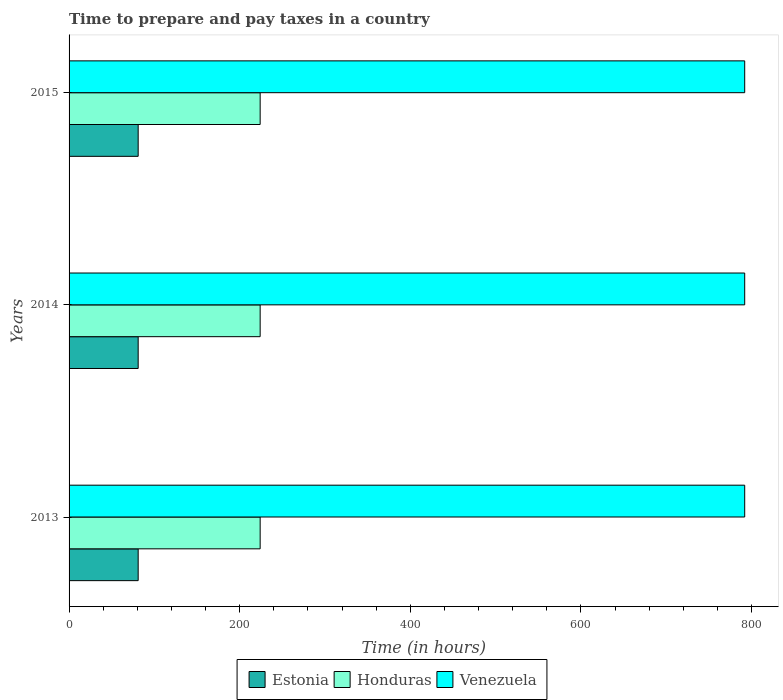How many bars are there on the 2nd tick from the top?
Provide a short and direct response. 3. In how many cases, is the number of bars for a given year not equal to the number of legend labels?
Offer a terse response. 0. What is the number of hours required to prepare and pay taxes in Venezuela in 2014?
Give a very brief answer. 792. Across all years, what is the maximum number of hours required to prepare and pay taxes in Venezuela?
Make the answer very short. 792. Across all years, what is the minimum number of hours required to prepare and pay taxes in Venezuela?
Your answer should be compact. 792. In which year was the number of hours required to prepare and pay taxes in Venezuela maximum?
Give a very brief answer. 2013. What is the total number of hours required to prepare and pay taxes in Honduras in the graph?
Provide a succinct answer. 672. What is the difference between the number of hours required to prepare and pay taxes in Honduras in 2014 and the number of hours required to prepare and pay taxes in Venezuela in 2015?
Ensure brevity in your answer.  -568. What is the average number of hours required to prepare and pay taxes in Honduras per year?
Offer a very short reply. 224. In the year 2013, what is the difference between the number of hours required to prepare and pay taxes in Honduras and number of hours required to prepare and pay taxes in Estonia?
Your answer should be very brief. 143. In how many years, is the number of hours required to prepare and pay taxes in Honduras greater than 440 hours?
Ensure brevity in your answer.  0. Is the difference between the number of hours required to prepare and pay taxes in Honduras in 2013 and 2015 greater than the difference between the number of hours required to prepare and pay taxes in Estonia in 2013 and 2015?
Your answer should be compact. No. Is the sum of the number of hours required to prepare and pay taxes in Estonia in 2014 and 2015 greater than the maximum number of hours required to prepare and pay taxes in Venezuela across all years?
Your response must be concise. No. What does the 2nd bar from the top in 2013 represents?
Offer a terse response. Honduras. What does the 1st bar from the bottom in 2013 represents?
Give a very brief answer. Estonia. How many bars are there?
Offer a terse response. 9. Are all the bars in the graph horizontal?
Offer a very short reply. Yes. Does the graph contain any zero values?
Provide a short and direct response. No. Where does the legend appear in the graph?
Make the answer very short. Bottom center. How many legend labels are there?
Keep it short and to the point. 3. What is the title of the graph?
Ensure brevity in your answer.  Time to prepare and pay taxes in a country. Does "Kenya" appear as one of the legend labels in the graph?
Provide a short and direct response. No. What is the label or title of the X-axis?
Your response must be concise. Time (in hours). What is the label or title of the Y-axis?
Ensure brevity in your answer.  Years. What is the Time (in hours) in Estonia in 2013?
Your answer should be compact. 81. What is the Time (in hours) in Honduras in 2013?
Provide a short and direct response. 224. What is the Time (in hours) in Venezuela in 2013?
Keep it short and to the point. 792. What is the Time (in hours) of Estonia in 2014?
Your answer should be compact. 81. What is the Time (in hours) of Honduras in 2014?
Offer a very short reply. 224. What is the Time (in hours) in Venezuela in 2014?
Offer a very short reply. 792. What is the Time (in hours) in Honduras in 2015?
Offer a very short reply. 224. What is the Time (in hours) of Venezuela in 2015?
Provide a succinct answer. 792. Across all years, what is the maximum Time (in hours) in Honduras?
Your answer should be compact. 224. Across all years, what is the maximum Time (in hours) of Venezuela?
Keep it short and to the point. 792. Across all years, what is the minimum Time (in hours) of Estonia?
Your answer should be compact. 81. Across all years, what is the minimum Time (in hours) in Honduras?
Provide a short and direct response. 224. Across all years, what is the minimum Time (in hours) of Venezuela?
Offer a very short reply. 792. What is the total Time (in hours) of Estonia in the graph?
Your answer should be very brief. 243. What is the total Time (in hours) of Honduras in the graph?
Your answer should be very brief. 672. What is the total Time (in hours) in Venezuela in the graph?
Provide a succinct answer. 2376. What is the difference between the Time (in hours) in Estonia in 2013 and that in 2014?
Your answer should be very brief. 0. What is the difference between the Time (in hours) in Honduras in 2013 and that in 2014?
Ensure brevity in your answer.  0. What is the difference between the Time (in hours) in Estonia in 2014 and that in 2015?
Make the answer very short. 0. What is the difference between the Time (in hours) of Estonia in 2013 and the Time (in hours) of Honduras in 2014?
Your answer should be compact. -143. What is the difference between the Time (in hours) of Estonia in 2013 and the Time (in hours) of Venezuela in 2014?
Your answer should be compact. -711. What is the difference between the Time (in hours) of Honduras in 2013 and the Time (in hours) of Venezuela in 2014?
Your response must be concise. -568. What is the difference between the Time (in hours) in Estonia in 2013 and the Time (in hours) in Honduras in 2015?
Offer a very short reply. -143. What is the difference between the Time (in hours) of Estonia in 2013 and the Time (in hours) of Venezuela in 2015?
Your response must be concise. -711. What is the difference between the Time (in hours) in Honduras in 2013 and the Time (in hours) in Venezuela in 2015?
Make the answer very short. -568. What is the difference between the Time (in hours) of Estonia in 2014 and the Time (in hours) of Honduras in 2015?
Give a very brief answer. -143. What is the difference between the Time (in hours) of Estonia in 2014 and the Time (in hours) of Venezuela in 2015?
Your response must be concise. -711. What is the difference between the Time (in hours) in Honduras in 2014 and the Time (in hours) in Venezuela in 2015?
Provide a succinct answer. -568. What is the average Time (in hours) in Honduras per year?
Your answer should be compact. 224. What is the average Time (in hours) of Venezuela per year?
Give a very brief answer. 792. In the year 2013, what is the difference between the Time (in hours) of Estonia and Time (in hours) of Honduras?
Make the answer very short. -143. In the year 2013, what is the difference between the Time (in hours) in Estonia and Time (in hours) in Venezuela?
Your answer should be very brief. -711. In the year 2013, what is the difference between the Time (in hours) in Honduras and Time (in hours) in Venezuela?
Offer a terse response. -568. In the year 2014, what is the difference between the Time (in hours) of Estonia and Time (in hours) of Honduras?
Offer a very short reply. -143. In the year 2014, what is the difference between the Time (in hours) of Estonia and Time (in hours) of Venezuela?
Provide a short and direct response. -711. In the year 2014, what is the difference between the Time (in hours) of Honduras and Time (in hours) of Venezuela?
Keep it short and to the point. -568. In the year 2015, what is the difference between the Time (in hours) of Estonia and Time (in hours) of Honduras?
Your response must be concise. -143. In the year 2015, what is the difference between the Time (in hours) in Estonia and Time (in hours) in Venezuela?
Offer a terse response. -711. In the year 2015, what is the difference between the Time (in hours) in Honduras and Time (in hours) in Venezuela?
Ensure brevity in your answer.  -568. What is the ratio of the Time (in hours) of Estonia in 2013 to that in 2015?
Make the answer very short. 1. What is the ratio of the Time (in hours) of Venezuela in 2013 to that in 2015?
Your response must be concise. 1. What is the ratio of the Time (in hours) in Estonia in 2014 to that in 2015?
Provide a succinct answer. 1. What is the ratio of the Time (in hours) of Venezuela in 2014 to that in 2015?
Offer a terse response. 1. What is the difference between the highest and the lowest Time (in hours) of Estonia?
Keep it short and to the point. 0. What is the difference between the highest and the lowest Time (in hours) in Honduras?
Ensure brevity in your answer.  0. 